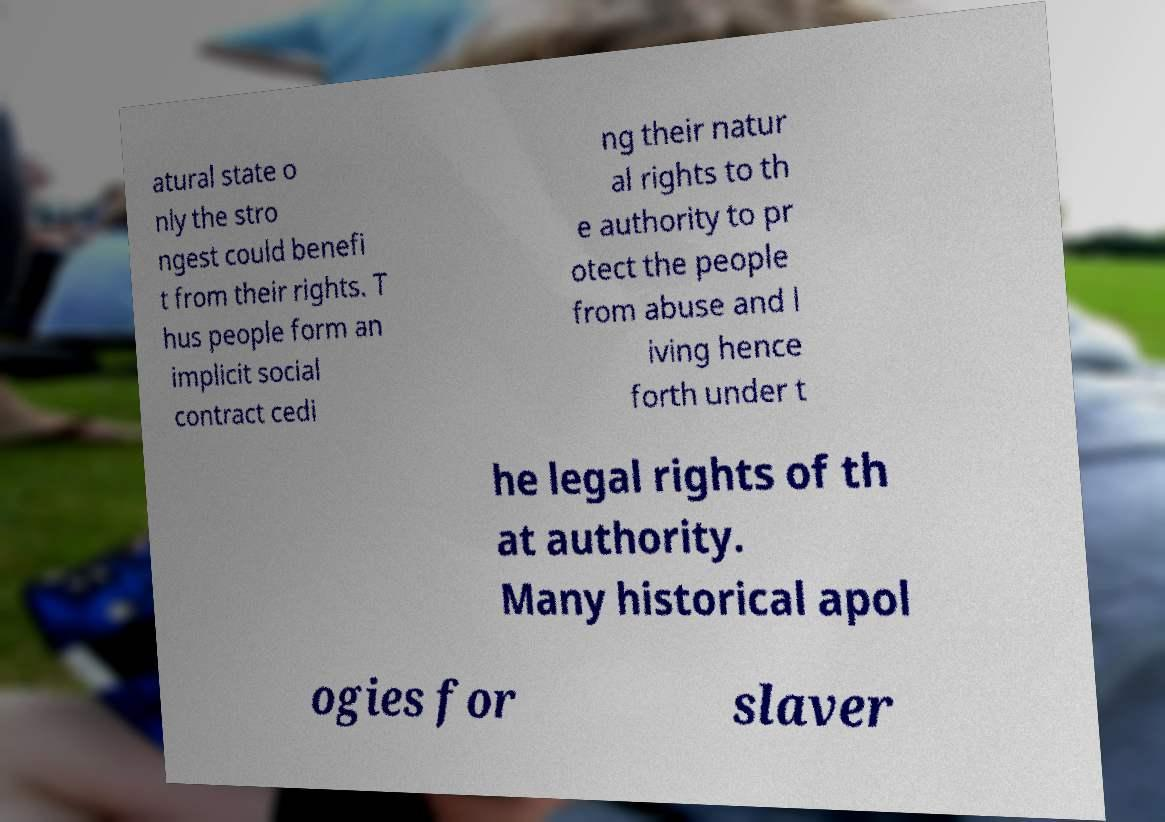What messages or text are displayed in this image? I need them in a readable, typed format. atural state o nly the stro ngest could benefi t from their rights. T hus people form an implicit social contract cedi ng their natur al rights to th e authority to pr otect the people from abuse and l iving hence forth under t he legal rights of th at authority. Many historical apol ogies for slaver 